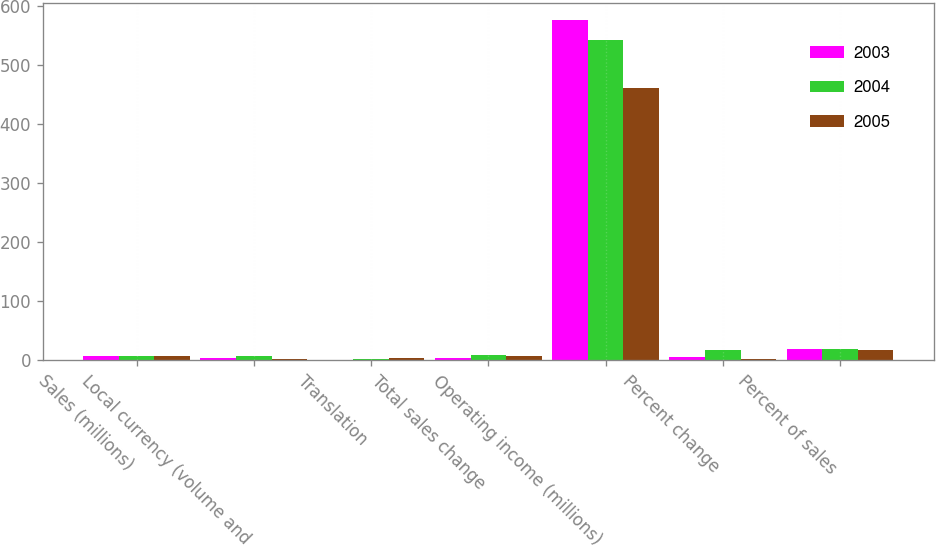Convert chart to OTSL. <chart><loc_0><loc_0><loc_500><loc_500><stacked_bar_chart><ecel><fcel>Sales (millions)<fcel>Local currency (volume and<fcel>Translation<fcel>Total sales change<fcel>Operating income (millions)<fcel>Percent change<fcel>Percent of sales<nl><fcel>2003<fcel>6.8<fcel>3.4<fcel>1<fcel>4.4<fcel>576<fcel>6.3<fcel>19.3<nl><fcel>2004<fcel>6.8<fcel>6.9<fcel>2.8<fcel>9.7<fcel>542<fcel>17.9<fcel>18.9<nl><fcel>2005<fcel>6.8<fcel>2.6<fcel>4.1<fcel>6.7<fcel>460<fcel>2.5<fcel>17.6<nl></chart> 